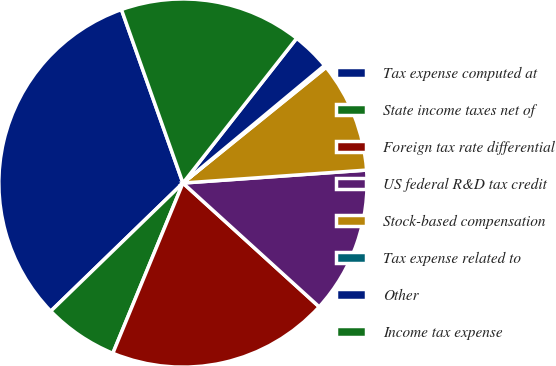Convert chart. <chart><loc_0><loc_0><loc_500><loc_500><pie_chart><fcel>Tax expense computed at<fcel>State income taxes net of<fcel>Foreign tax rate differential<fcel>US federal R&D tax credit<fcel>Stock-based compensation<fcel>Tax expense related to<fcel>Other<fcel>Income tax expense<nl><fcel>31.83%<fcel>6.53%<fcel>19.48%<fcel>12.86%<fcel>9.7%<fcel>0.21%<fcel>3.37%<fcel>16.02%<nl></chart> 